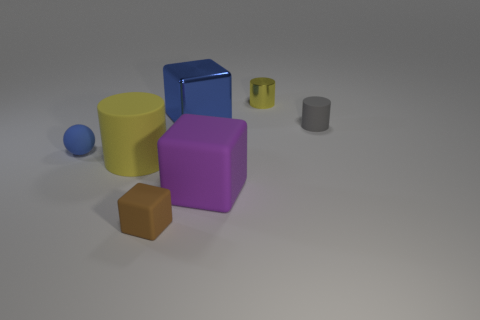Add 3 purple blocks. How many objects exist? 10 Subtract all spheres. How many objects are left? 6 Add 7 tiny rubber cylinders. How many tiny rubber cylinders exist? 8 Subtract 0 cyan cubes. How many objects are left? 7 Subtract all gray things. Subtract all big green blocks. How many objects are left? 6 Add 4 large purple things. How many large purple things are left? 5 